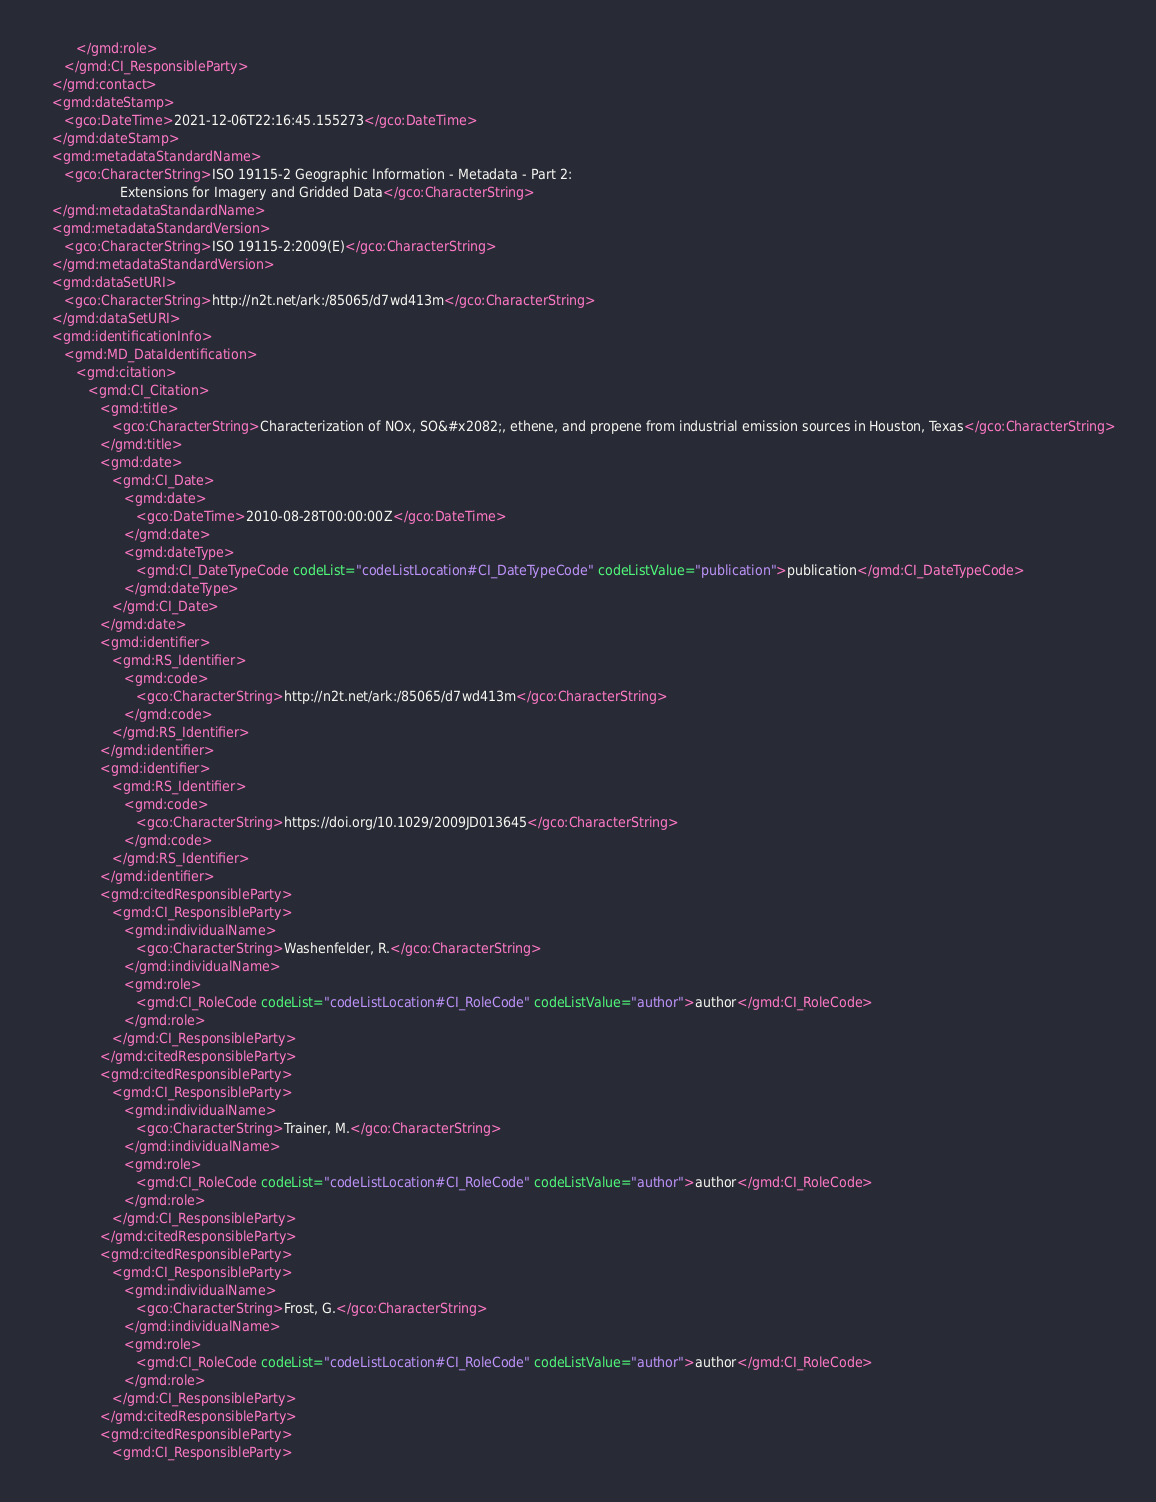Convert code to text. <code><loc_0><loc_0><loc_500><loc_500><_XML_>         </gmd:role>
      </gmd:CI_ResponsibleParty>
   </gmd:contact>
   <gmd:dateStamp>
      <gco:DateTime>2021-12-06T22:16:45.155273</gco:DateTime>
   </gmd:dateStamp>
   <gmd:metadataStandardName>
      <gco:CharacterString>ISO 19115-2 Geographic Information - Metadata - Part 2:
                    Extensions for Imagery and Gridded Data</gco:CharacterString>
   </gmd:metadataStandardName>
   <gmd:metadataStandardVersion>
      <gco:CharacterString>ISO 19115-2:2009(E)</gco:CharacterString>
   </gmd:metadataStandardVersion>
   <gmd:dataSetURI>
      <gco:CharacterString>http://n2t.net/ark:/85065/d7wd413m</gco:CharacterString>
   </gmd:dataSetURI>
   <gmd:identificationInfo>
      <gmd:MD_DataIdentification>
         <gmd:citation>
            <gmd:CI_Citation>
               <gmd:title>
                  <gco:CharacterString>Characterization of NOx, SO&#x2082;, ethene, and propene from industrial emission sources in Houston, Texas</gco:CharacterString>
               </gmd:title>
               <gmd:date>
                  <gmd:CI_Date>
                     <gmd:date>
                        <gco:DateTime>2010-08-28T00:00:00Z</gco:DateTime>
                     </gmd:date>
                     <gmd:dateType>
                        <gmd:CI_DateTypeCode codeList="codeListLocation#CI_DateTypeCode" codeListValue="publication">publication</gmd:CI_DateTypeCode>
                     </gmd:dateType>
                  </gmd:CI_Date>
               </gmd:date>
               <gmd:identifier>
                  <gmd:RS_Identifier>
                     <gmd:code>
                        <gco:CharacterString>http://n2t.net/ark:/85065/d7wd413m</gco:CharacterString>
                     </gmd:code>
                  </gmd:RS_Identifier>
               </gmd:identifier>
               <gmd:identifier>
                  <gmd:RS_Identifier>
                     <gmd:code>
                        <gco:CharacterString>https://doi.org/10.1029/2009JD013645</gco:CharacterString>
                     </gmd:code>
                  </gmd:RS_Identifier>
               </gmd:identifier>
               <gmd:citedResponsibleParty>
                  <gmd:CI_ResponsibleParty>
                     <gmd:individualName>
                        <gco:CharacterString>Washenfelder, R.</gco:CharacterString>
                     </gmd:individualName>
                     <gmd:role>
                        <gmd:CI_RoleCode codeList="codeListLocation#CI_RoleCode" codeListValue="author">author</gmd:CI_RoleCode>
                     </gmd:role>
                  </gmd:CI_ResponsibleParty>
               </gmd:citedResponsibleParty>
               <gmd:citedResponsibleParty>
                  <gmd:CI_ResponsibleParty>
                     <gmd:individualName>
                        <gco:CharacterString>Trainer, M.</gco:CharacterString>
                     </gmd:individualName>
                     <gmd:role>
                        <gmd:CI_RoleCode codeList="codeListLocation#CI_RoleCode" codeListValue="author">author</gmd:CI_RoleCode>
                     </gmd:role>
                  </gmd:CI_ResponsibleParty>
               </gmd:citedResponsibleParty>
               <gmd:citedResponsibleParty>
                  <gmd:CI_ResponsibleParty>
                     <gmd:individualName>
                        <gco:CharacterString>Frost, G.</gco:CharacterString>
                     </gmd:individualName>
                     <gmd:role>
                        <gmd:CI_RoleCode codeList="codeListLocation#CI_RoleCode" codeListValue="author">author</gmd:CI_RoleCode>
                     </gmd:role>
                  </gmd:CI_ResponsibleParty>
               </gmd:citedResponsibleParty>
               <gmd:citedResponsibleParty>
                  <gmd:CI_ResponsibleParty></code> 